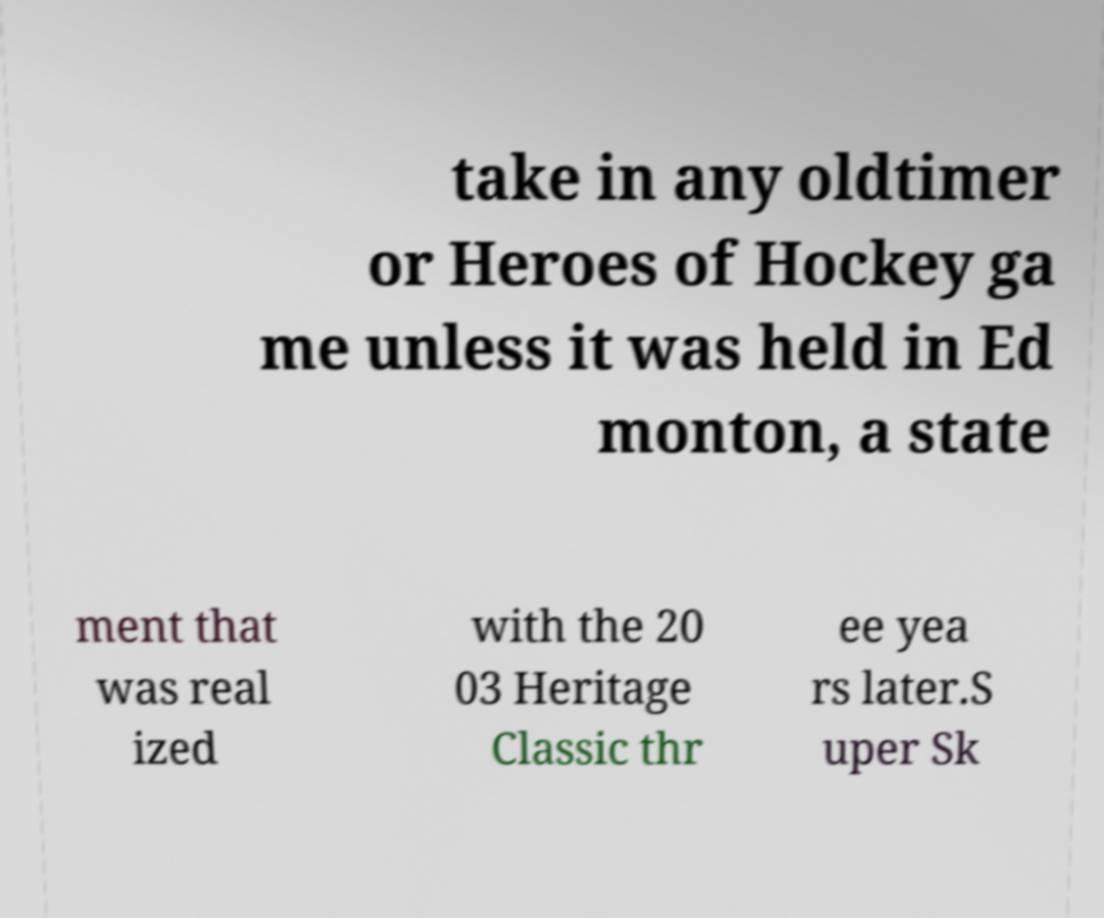Please identify and transcribe the text found in this image. take in any oldtimer or Heroes of Hockey ga me unless it was held in Ed monton, a state ment that was real ized with the 20 03 Heritage Classic thr ee yea rs later.S uper Sk 